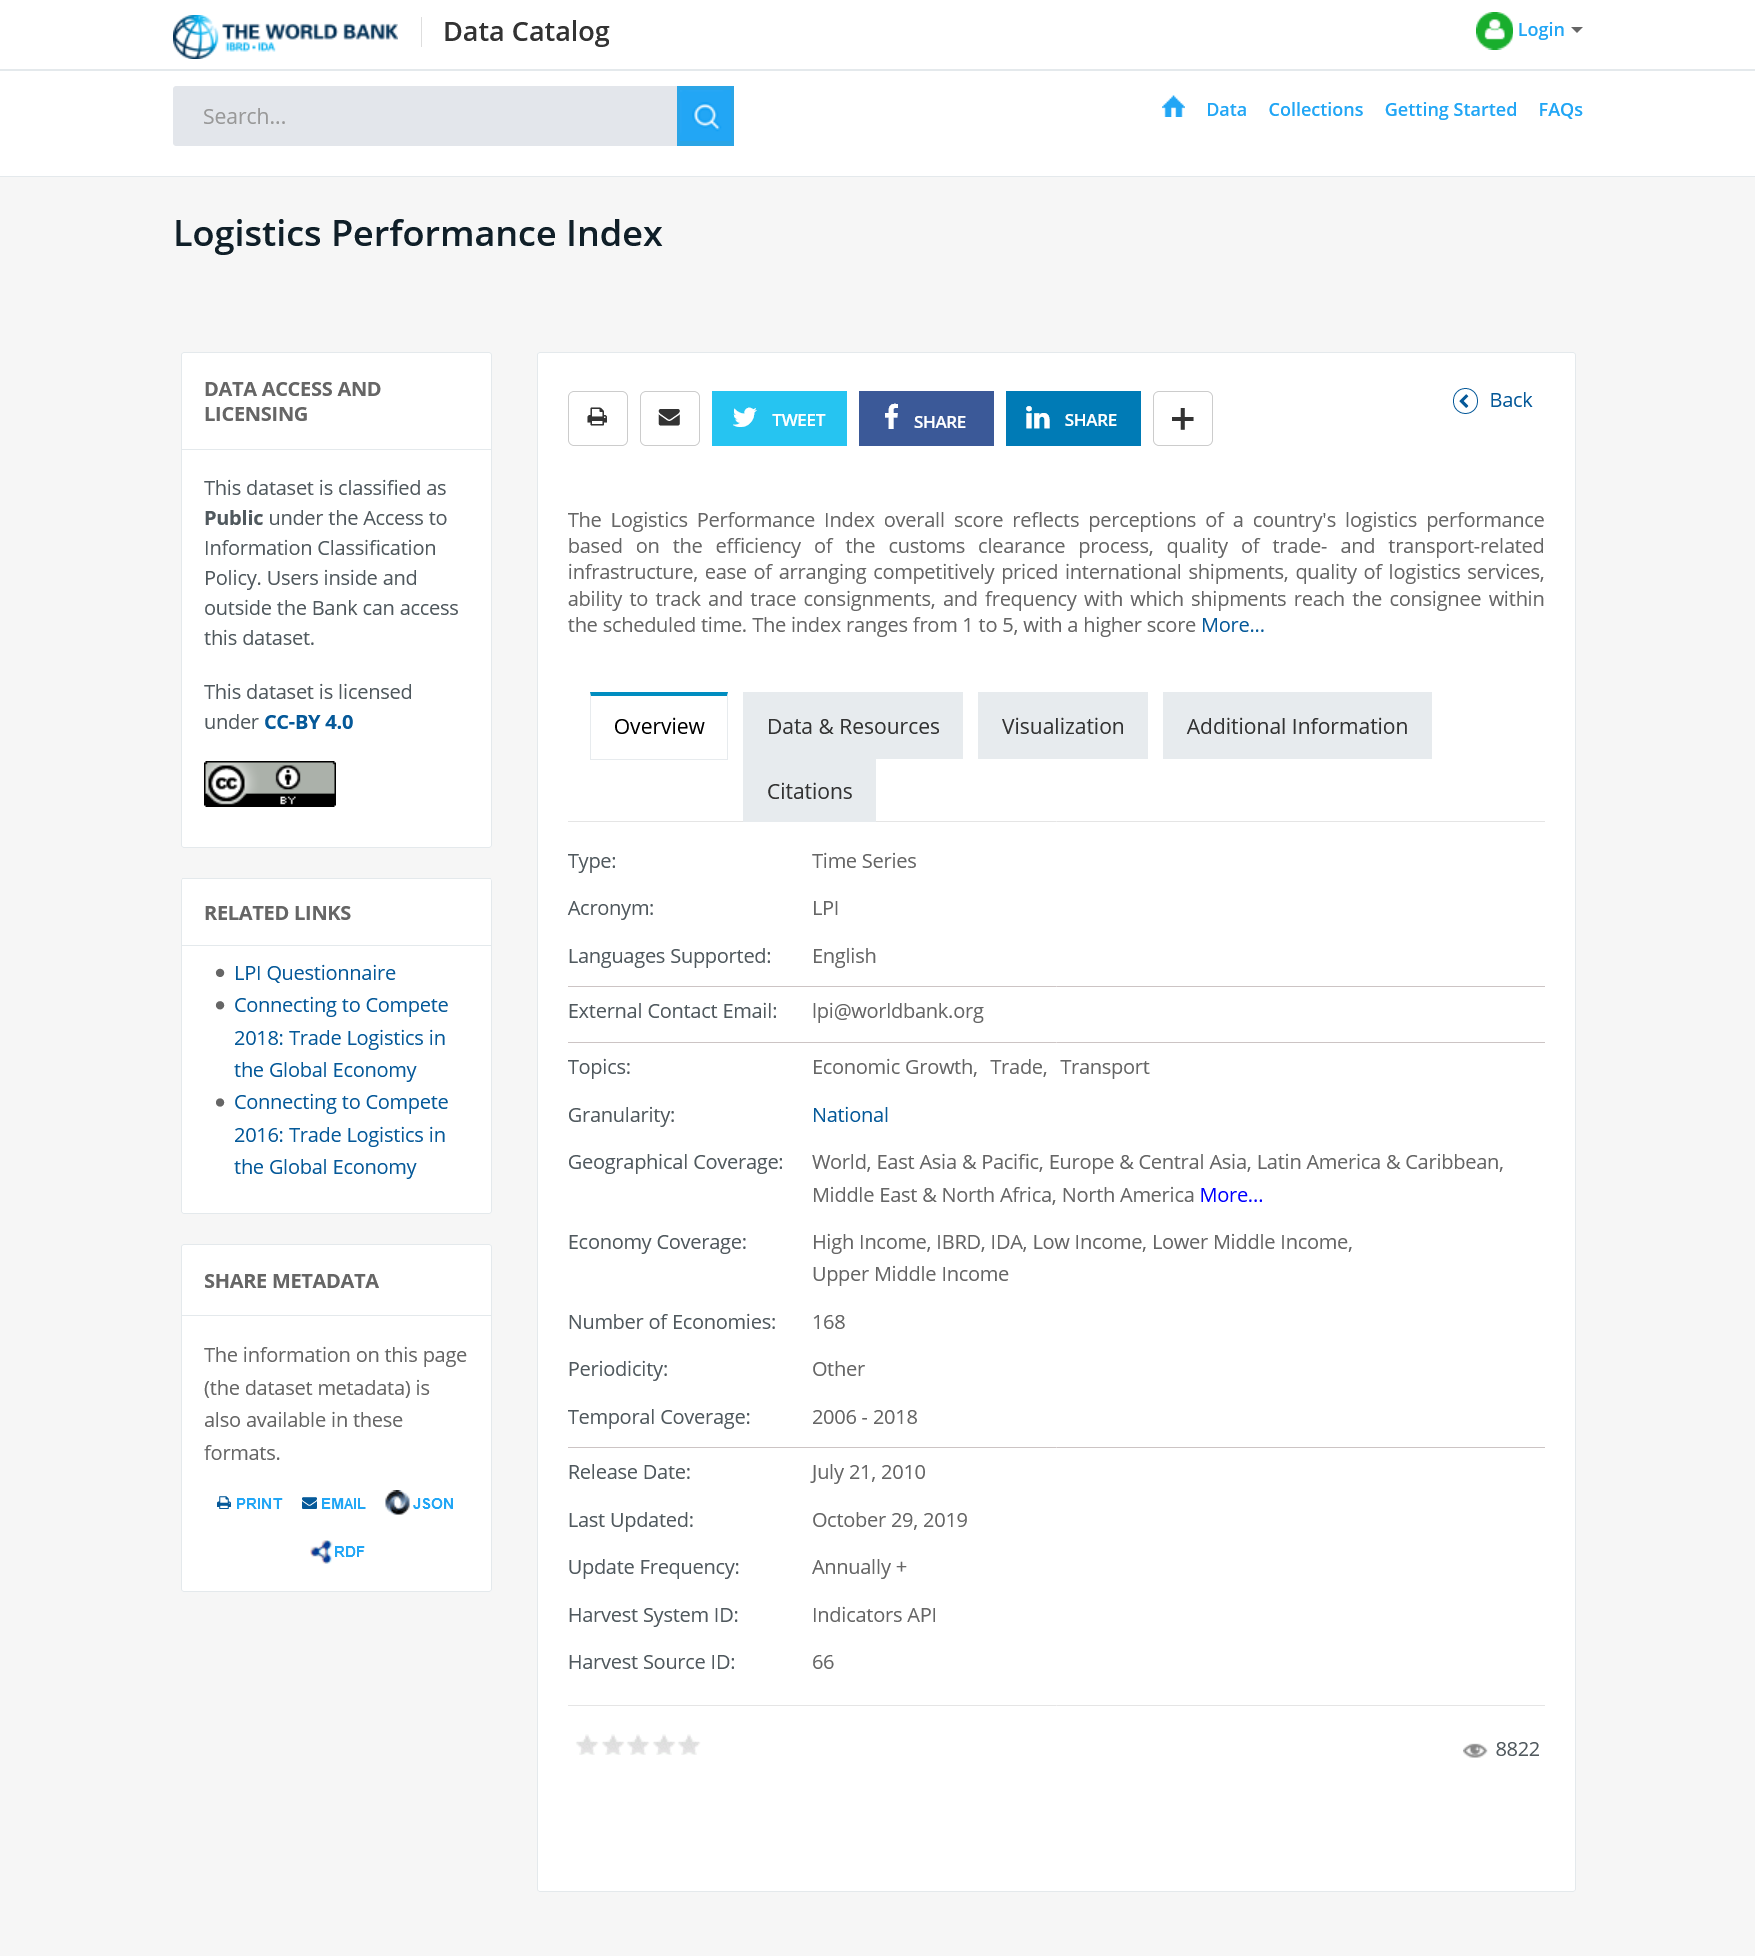Outline some significant characteristics in this image. The Logistics Performance Index of a country is a measure of its perceived logistics performance, which is reflected in its overall score. The Logistics Performance Index overall score is determined by various factors, such as the efficiency of customs clearance, the quality of transport- and trade-related infrastructure, the affordability of international shipments, the availability of reliable logistics services, the ability to track and trace consignments, and the punctuality of delivered shipments. The range of scores available for the overall Logistics Performance Index of a country is from 1 to 5, with a score of 1 indicating the lowest level of logistics performance and a score of 5 indicating the highest level of logistics performance. 